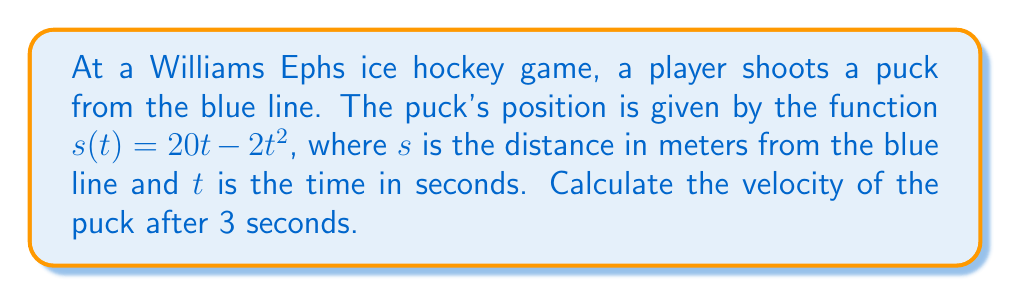Could you help me with this problem? To find the velocity of the puck, we need to differentiate the position function with respect to time.

1. Given position function: $s(t) = 20t - 2t^2$

2. Velocity is the first derivative of position:
   $v(t) = \frac{ds}{dt} = \frac{d}{dt}(20t - 2t^2)$

3. Apply the power rule of differentiation:
   $v(t) = 20 - 4t$

4. To find the velocity at 3 seconds, substitute $t = 3$:
   $v(3) = 20 - 4(3) = 20 - 12 = 8$

Therefore, the velocity of the puck after 3 seconds is 8 meters per second.
Answer: 8 m/s 